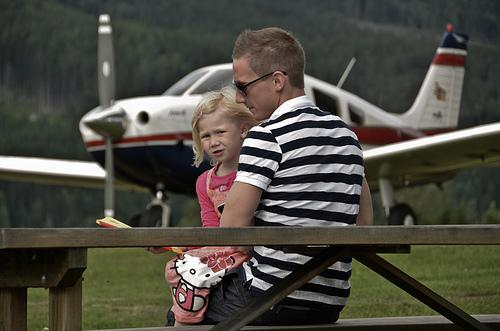Question: how many men are in this picture?
Choices:
A. Two.
B. One.
C. Four.
D. Six.
Answer with the letter. Answer: B Question: what color is the girl's shirt?
Choices:
A. Pink.
B. Red.
C. Blue.
D. Yellow.
Answer with the letter. Answer: A Question: where was this picture likely taken?
Choices:
A. The runway.
B. A train station.
C. A bus stop.
D. An airport.
Answer with the letter. Answer: D Question: what color is the ground in this picture?
Choices:
A. Grey.
B. White.
C. Black.
D. Green.
Answer with the letter. Answer: D 